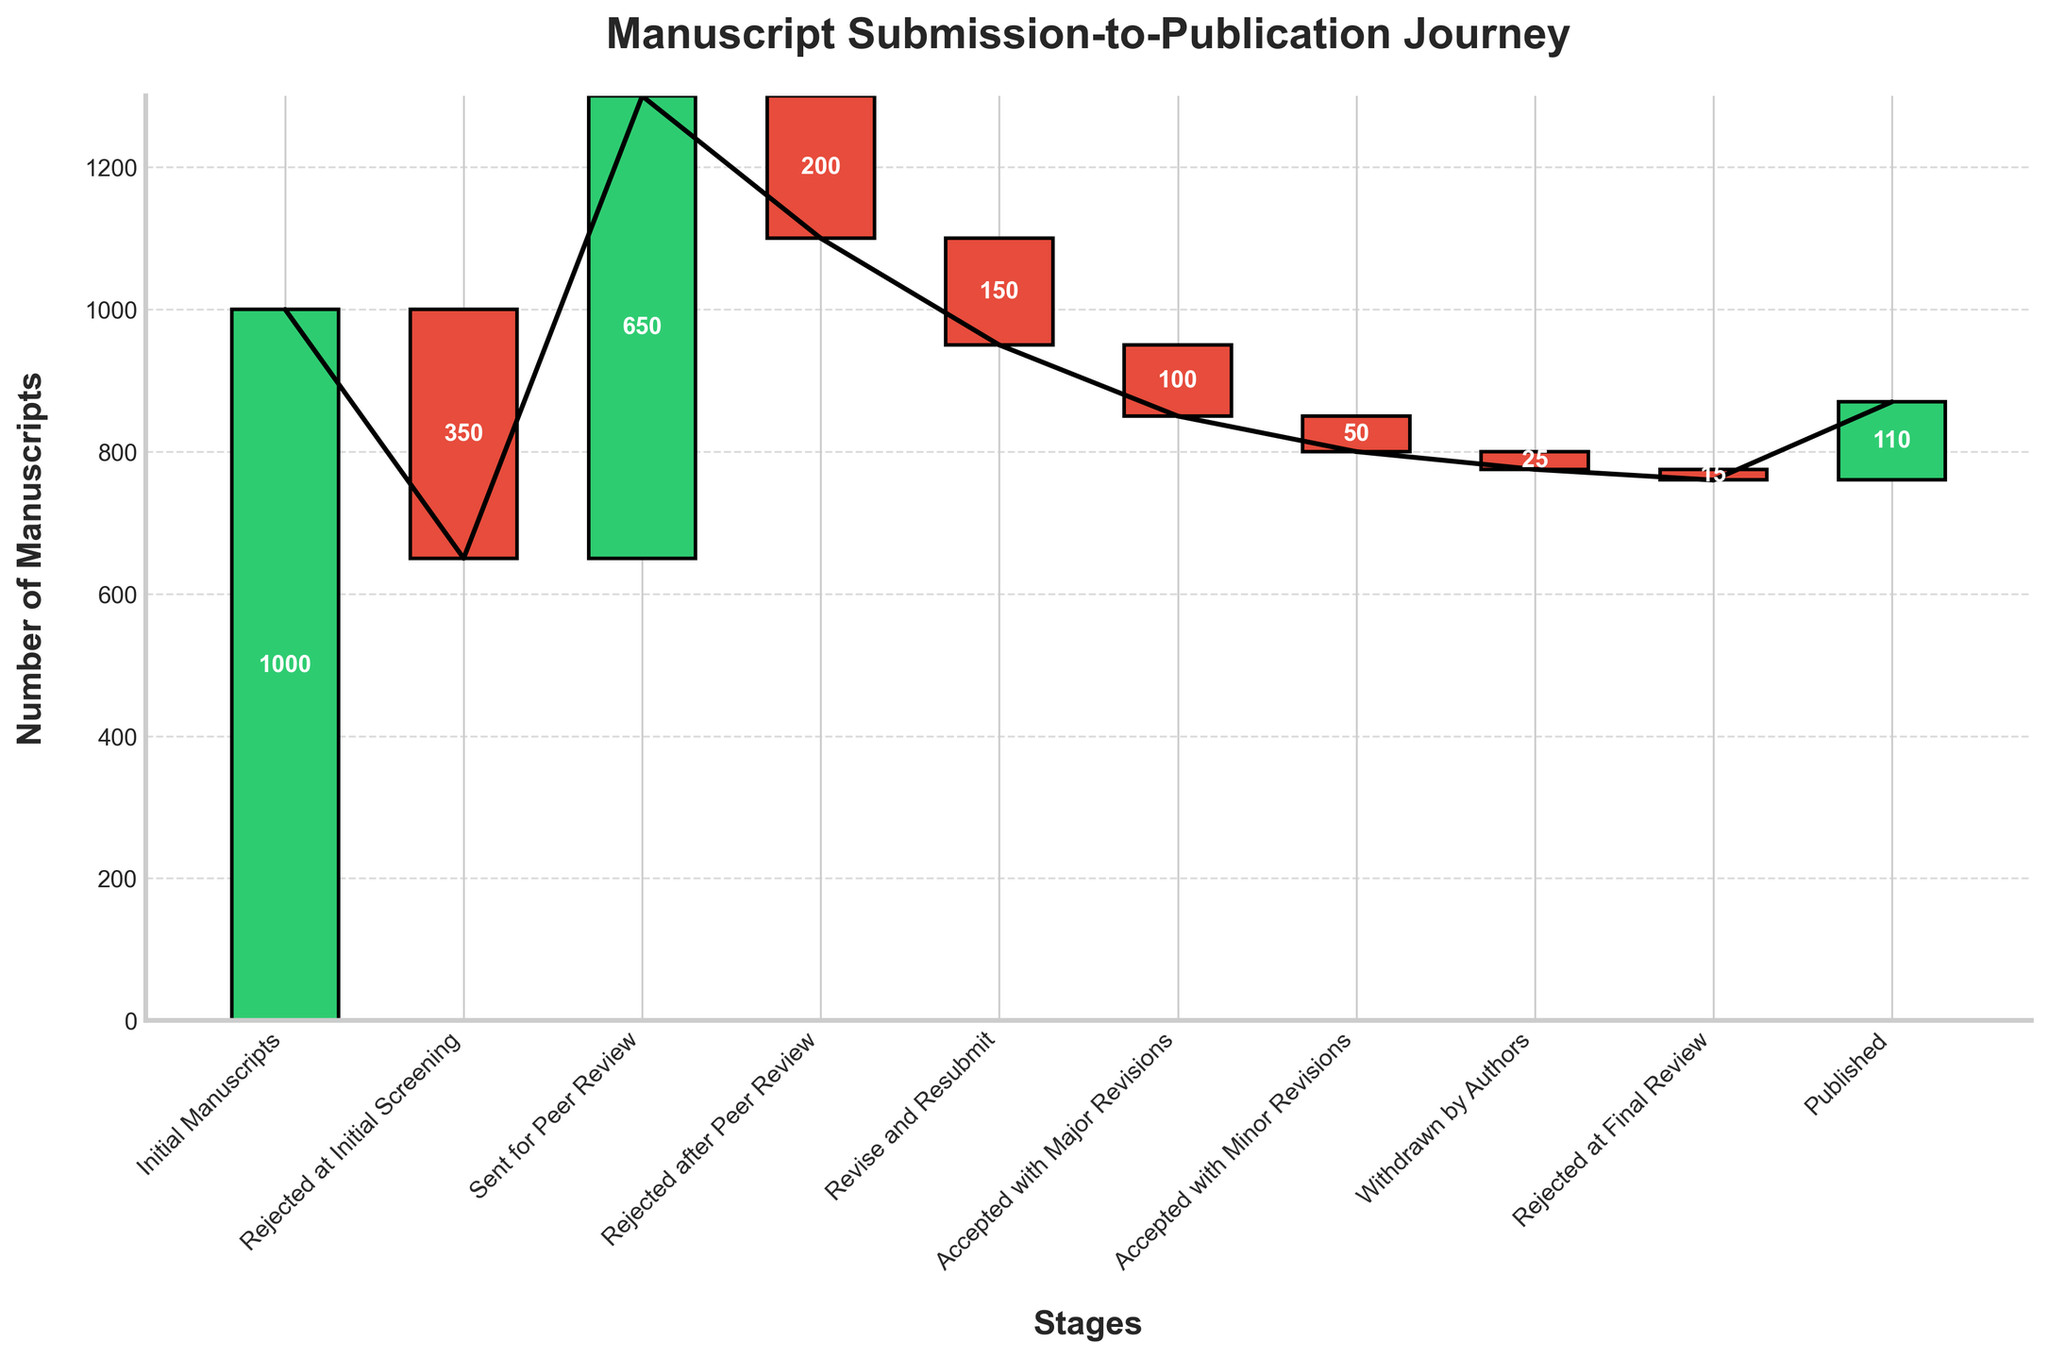What's the title of the chart? The title of the chart is usually displayed prominently at the top of the figure. It specifies what the chart represents.
Answer: Manuscript Submission-to-Publication Journey How many manuscripts were initially submitted? The initial number of manuscripts is indicated at the very first stage of the chart.
Answer: 1000 Which stage has the highest number of rejections? To find the stage with the highest number of rejections, look for the stage with the largest negative value.
Answer: Rejected at Initial Screening How many manuscripts were withdrawn by authors? Identify the "Withdrawn by Authors" stage and note the value associated with it.
Answer: 25 How many manuscripts were accepted with major revisions? Identify the "Accepted with Major Revisions" stage and note the value associated with it.
Answer: 100 What is the final number of published manuscripts compared to those initially submitted? The initial number of manuscripts is given, and the final number of published manuscripts is indicated at the last stage. Subtract the final from the initial to get the difference.
Answer: 890 Which stage follows after "Sent for Peer Review"? Look at the sequence of stages after "Sent for Peer Review" to determine the next one.
Answer: Rejected after Peer Review What is the cumulative number of manuscripts before any rejections? The cumulative total before any rejections is simply the initial number of manuscripts, as no rejections have occurred yet.
Answer: 1000 What is the net loss of manuscripts at the "Rejected after Peer Review" stage? The net loss is shown as a negative value in that stage.
Answer: 200 Compare the number of manuscripts that required major revisions to those that required minor revisions. Look at the values associated with "Accepted with Major Revisions" and "Accepted with Minor Revisions". The former is larger.
Answer: Major Revisions are more by 50 